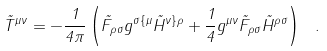Convert formula to latex. <formula><loc_0><loc_0><loc_500><loc_500>\tilde { T } ^ { \mu \nu } = - \frac { 1 } { 4 \pi } \left ( \tilde { F } _ { \rho \sigma } g ^ { \sigma \{ \mu } \tilde { H } ^ { \nu \} \rho } + \frac { 1 } { 4 } g ^ { \mu \nu } \tilde { F } _ { \rho \sigma } \tilde { H } ^ { \rho \sigma } \right ) \ .</formula> 